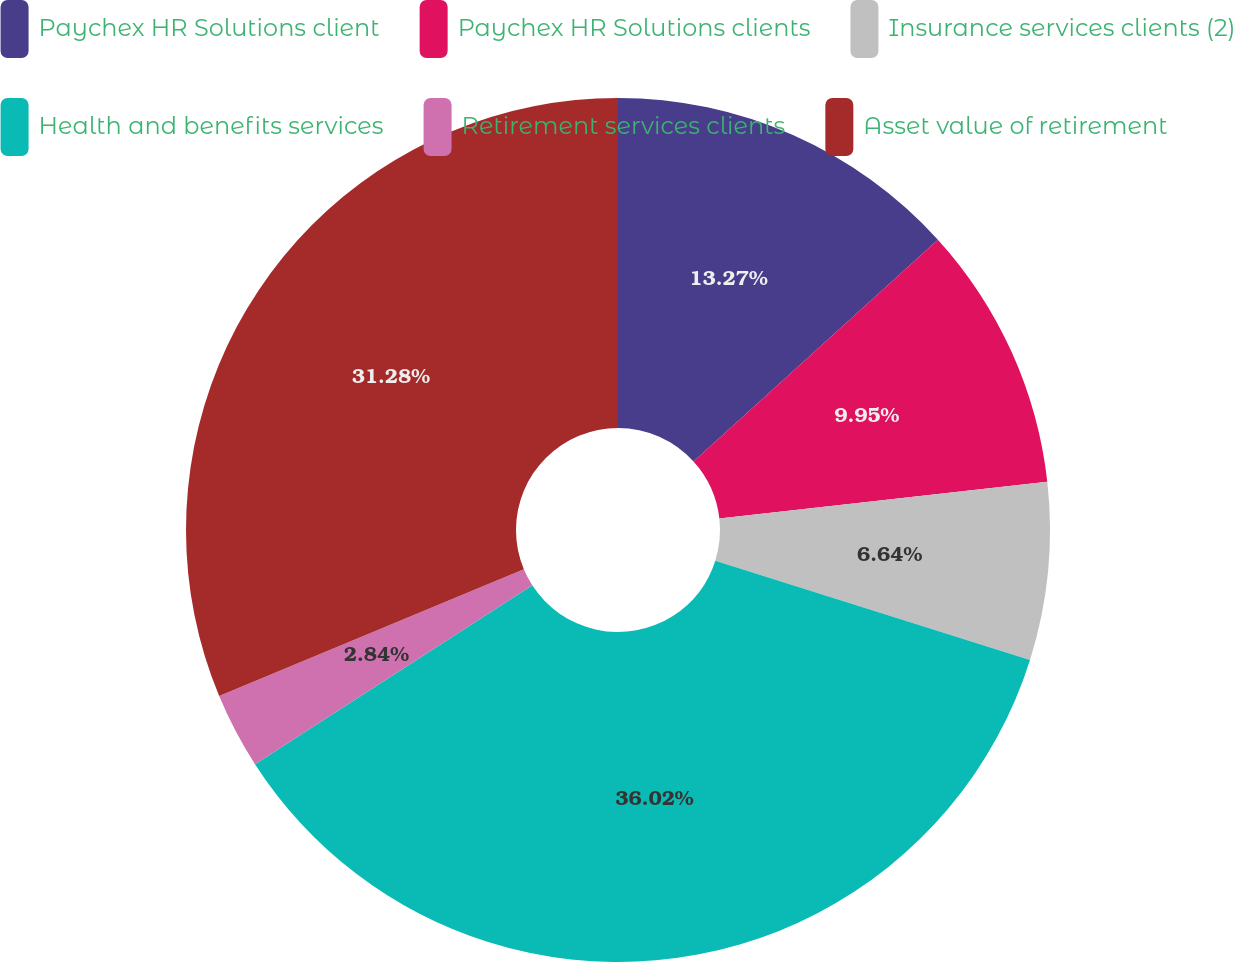Convert chart. <chart><loc_0><loc_0><loc_500><loc_500><pie_chart><fcel>Paychex HR Solutions client<fcel>Paychex HR Solutions clients<fcel>Insurance services clients (2)<fcel>Health and benefits services<fcel>Retirement services clients<fcel>Asset value of retirement<nl><fcel>13.27%<fcel>9.95%<fcel>6.64%<fcel>36.02%<fcel>2.84%<fcel>31.28%<nl></chart> 